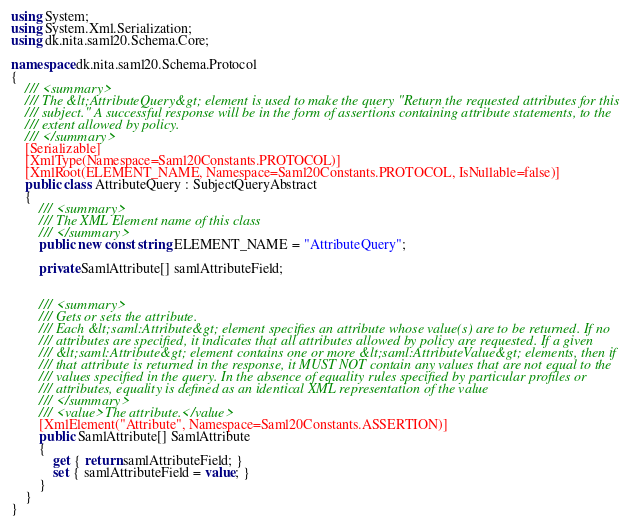Convert code to text. <code><loc_0><loc_0><loc_500><loc_500><_C#_>using System;
using System.Xml.Serialization;
using dk.nita.saml20.Schema.Core;

namespace dk.nita.saml20.Schema.Protocol
{
    /// <summary>
    /// The &lt;AttributeQuery&gt; element is used to make the query "Return the requested attributes for this
    /// subject." A successful response will be in the form of assertions containing attribute statements, to the
    /// extent allowed by policy.
    /// </summary>
    [Serializable]
    [XmlType(Namespace=Saml20Constants.PROTOCOL)]
    [XmlRoot(ELEMENT_NAME, Namespace=Saml20Constants.PROTOCOL, IsNullable=false)]
    public class AttributeQuery : SubjectQueryAbstract
    {
        /// <summary>
        /// The XML Element name of this class
        /// </summary>
        public new const string ELEMENT_NAME = "AttributeQuery";

        private SamlAttribute[] samlAttributeField;


        /// <summary>
        /// Gets or sets the attribute.
        /// Each &lt;saml:Attribute&gt; element specifies an attribute whose value(s) are to be returned. If no
        /// attributes are specified, it indicates that all attributes allowed by policy are requested. If a given
        /// &lt;saml:Attribute&gt; element contains one or more &lt;saml:AttributeValue&gt; elements, then if
        /// that attribute is returned in the response, it MUST NOT contain any values that are not equal to the
        /// values specified in the query. In the absence of equality rules specified by particular profiles or
        /// attributes, equality is defined as an identical XML representation of the value
        /// </summary>
        /// <value>The attribute.</value>
        [XmlElement("Attribute", Namespace=Saml20Constants.ASSERTION)]
        public SamlAttribute[] SamlAttribute
        {
            get { return samlAttributeField; }
            set { samlAttributeField = value; }
        }
    }
}</code> 